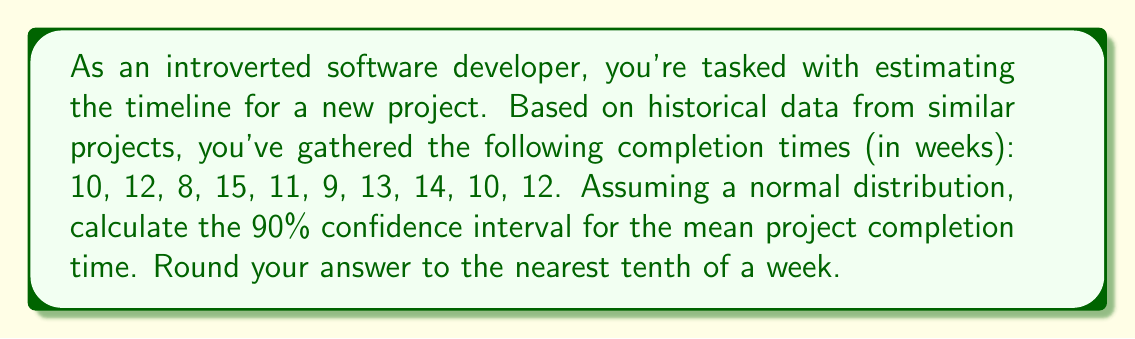Could you help me with this problem? Let's approach this step-by-step:

1) First, we need to calculate the sample mean ($\bar{x}$) and sample standard deviation ($s$).

   Mean: $\bar{x} = \frac{10 + 12 + 8 + 15 + 11 + 9 + 13 + 14 + 10 + 12}{10} = 11.4$ weeks

   For standard deviation:
   $s = \sqrt{\frac{\sum(x_i - \bar{x})^2}{n-1}}$
   
   $s = \sqrt{\frac{(10-11.4)^2 + (12-11.4)^2 + ... + (12-11.4)^2}{9}} \approx 2.221$ weeks

2) The formula for the confidence interval is:

   $\bar{x} \pm t_{\alpha/2, n-1} \cdot \frac{s}{\sqrt{n}}$

   Where $t_{\alpha/2, n-1}$ is the t-value for a 90% confidence interval with n-1 degrees of freedom.

3) For a 90% confidence interval, $\alpha = 0.1$, and we have 9 degrees of freedom (n-1 = 10-1 = 9).
   Looking up the t-value in a t-table, we find $t_{0.05, 9} \approx 1.833$

4) Now we can calculate the margin of error:

   $1.833 \cdot \frac{2.221}{\sqrt{10}} \approx 1.288$

5) Therefore, the 90% confidence interval is:

   $11.4 \pm 1.288$

   Or $[10.112, 12.688]$

6) Rounding to the nearest tenth:

   $[10.1, 12.7]$ weeks
Answer: [10.1, 12.7] weeks 